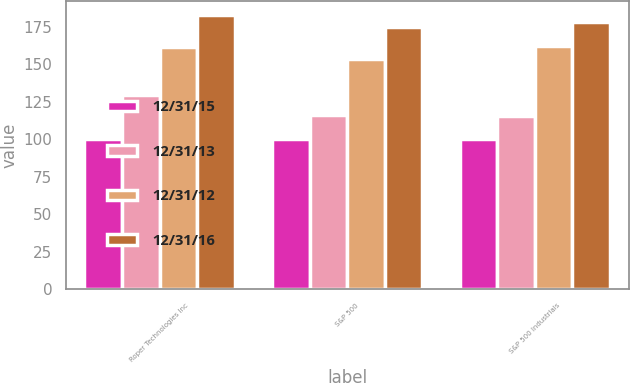Convert chart to OTSL. <chart><loc_0><loc_0><loc_500><loc_500><stacked_bar_chart><ecel><fcel>Roper Technologies Inc<fcel>S&P 500<fcel>S&P 500 Industrials<nl><fcel>12/31/15<fcel>100<fcel>100<fcel>100<nl><fcel>12/31/13<fcel>129.26<fcel>116<fcel>115.35<nl><fcel>12/31/12<fcel>161.43<fcel>153.58<fcel>162.27<nl><fcel>12/31/16<fcel>183.03<fcel>174.6<fcel>178.21<nl></chart> 